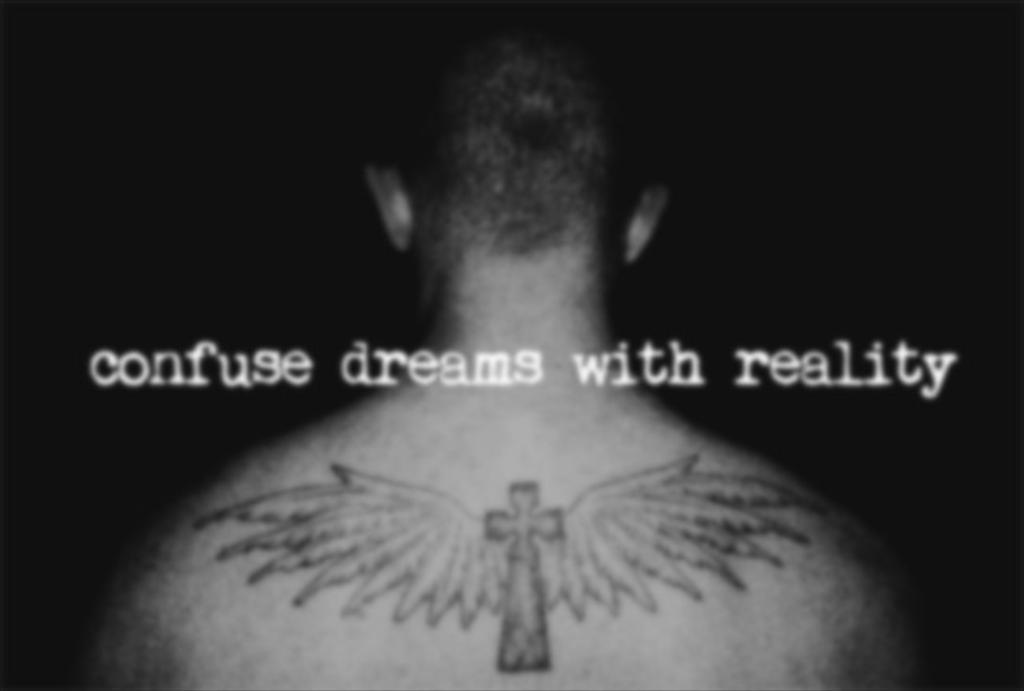What is the main subject of the image? There is a person's body in the image. Are there any distinguishing features on the person's body? Yes, the person has a tattoo. What else can be seen in the middle of the image? There are words written in the middle of the image. How many kittens are sitting on the person's tattoo in the image? There are no kittens present in the image, and therefore no kittens can be seen on the person's tattoo. 